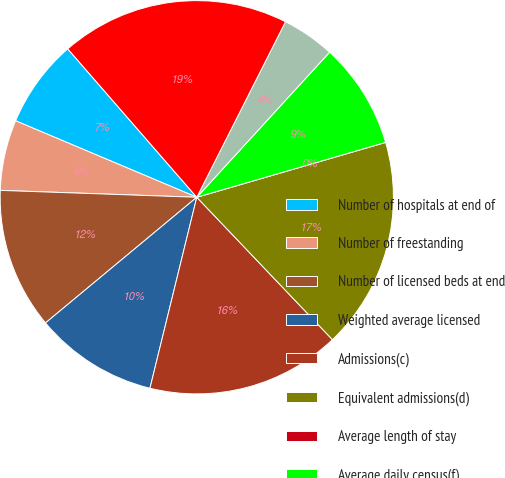Convert chart. <chart><loc_0><loc_0><loc_500><loc_500><pie_chart><fcel>Number of hospitals at end of<fcel>Number of freestanding<fcel>Number of licensed beds at end<fcel>Weighted average licensed<fcel>Admissions(c)<fcel>Equivalent admissions(d)<fcel>Average length of stay<fcel>Average daily census(f)<fcel>Occupancy(g)<fcel>Emergency room visits(h)<nl><fcel>7.25%<fcel>5.8%<fcel>11.59%<fcel>10.14%<fcel>15.94%<fcel>17.39%<fcel>0.0%<fcel>8.7%<fcel>4.35%<fcel>18.84%<nl></chart> 